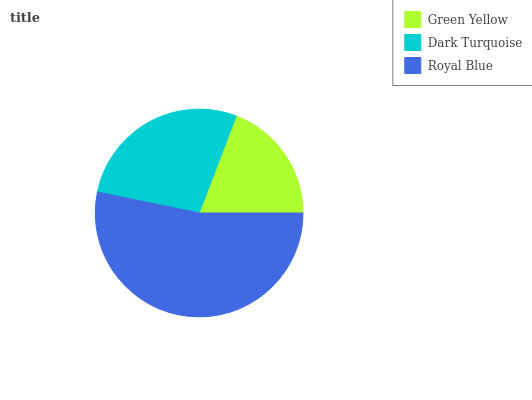Is Green Yellow the minimum?
Answer yes or no. Yes. Is Royal Blue the maximum?
Answer yes or no. Yes. Is Dark Turquoise the minimum?
Answer yes or no. No. Is Dark Turquoise the maximum?
Answer yes or no. No. Is Dark Turquoise greater than Green Yellow?
Answer yes or no. Yes. Is Green Yellow less than Dark Turquoise?
Answer yes or no. Yes. Is Green Yellow greater than Dark Turquoise?
Answer yes or no. No. Is Dark Turquoise less than Green Yellow?
Answer yes or no. No. Is Dark Turquoise the high median?
Answer yes or no. Yes. Is Dark Turquoise the low median?
Answer yes or no. Yes. Is Green Yellow the high median?
Answer yes or no. No. Is Royal Blue the low median?
Answer yes or no. No. 